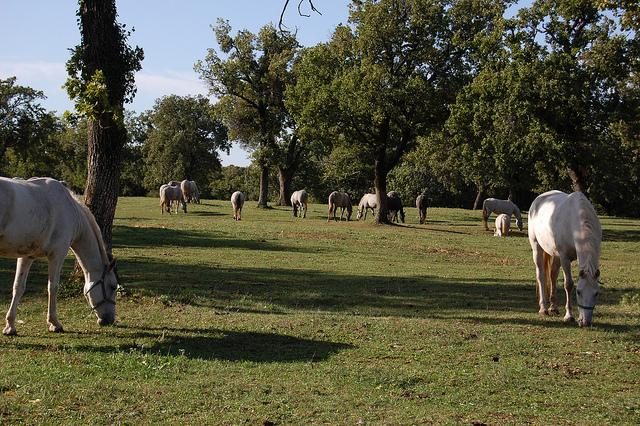What animals are present? Please explain your reasoning. horse. The animal is a horse. 